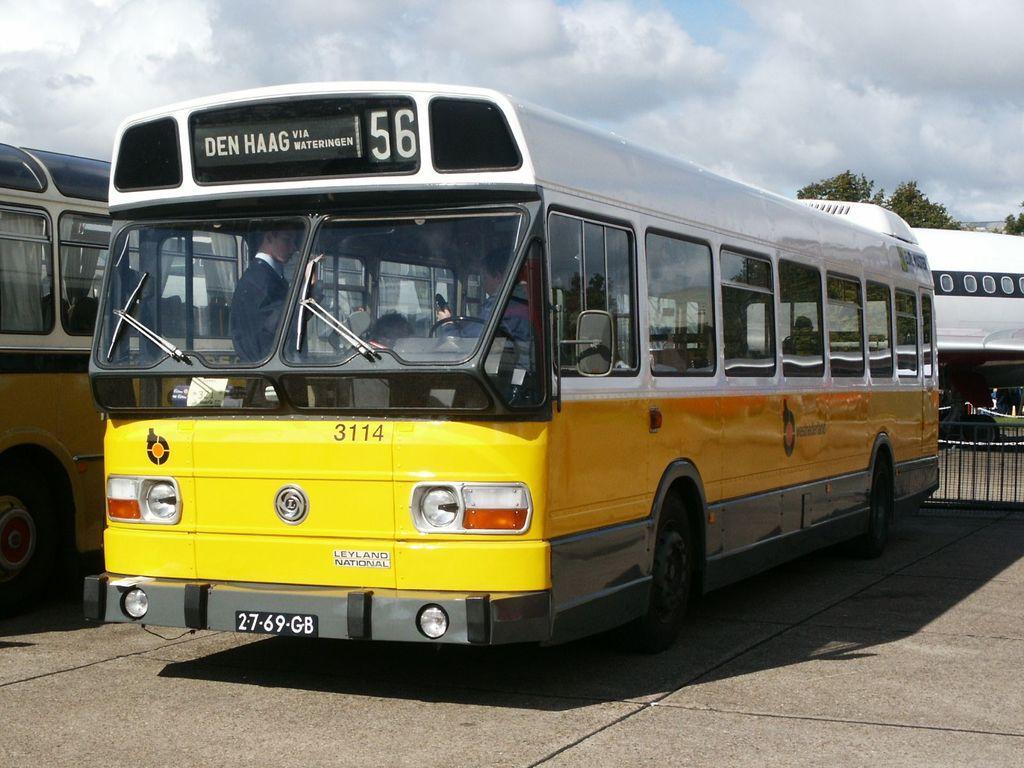Can you describe this image briefly? On the left side, there are two buses on a road. In one of these buses, there are persons. In the background, there are trees, an aircraft, a fence and there are clouds in the sky. 